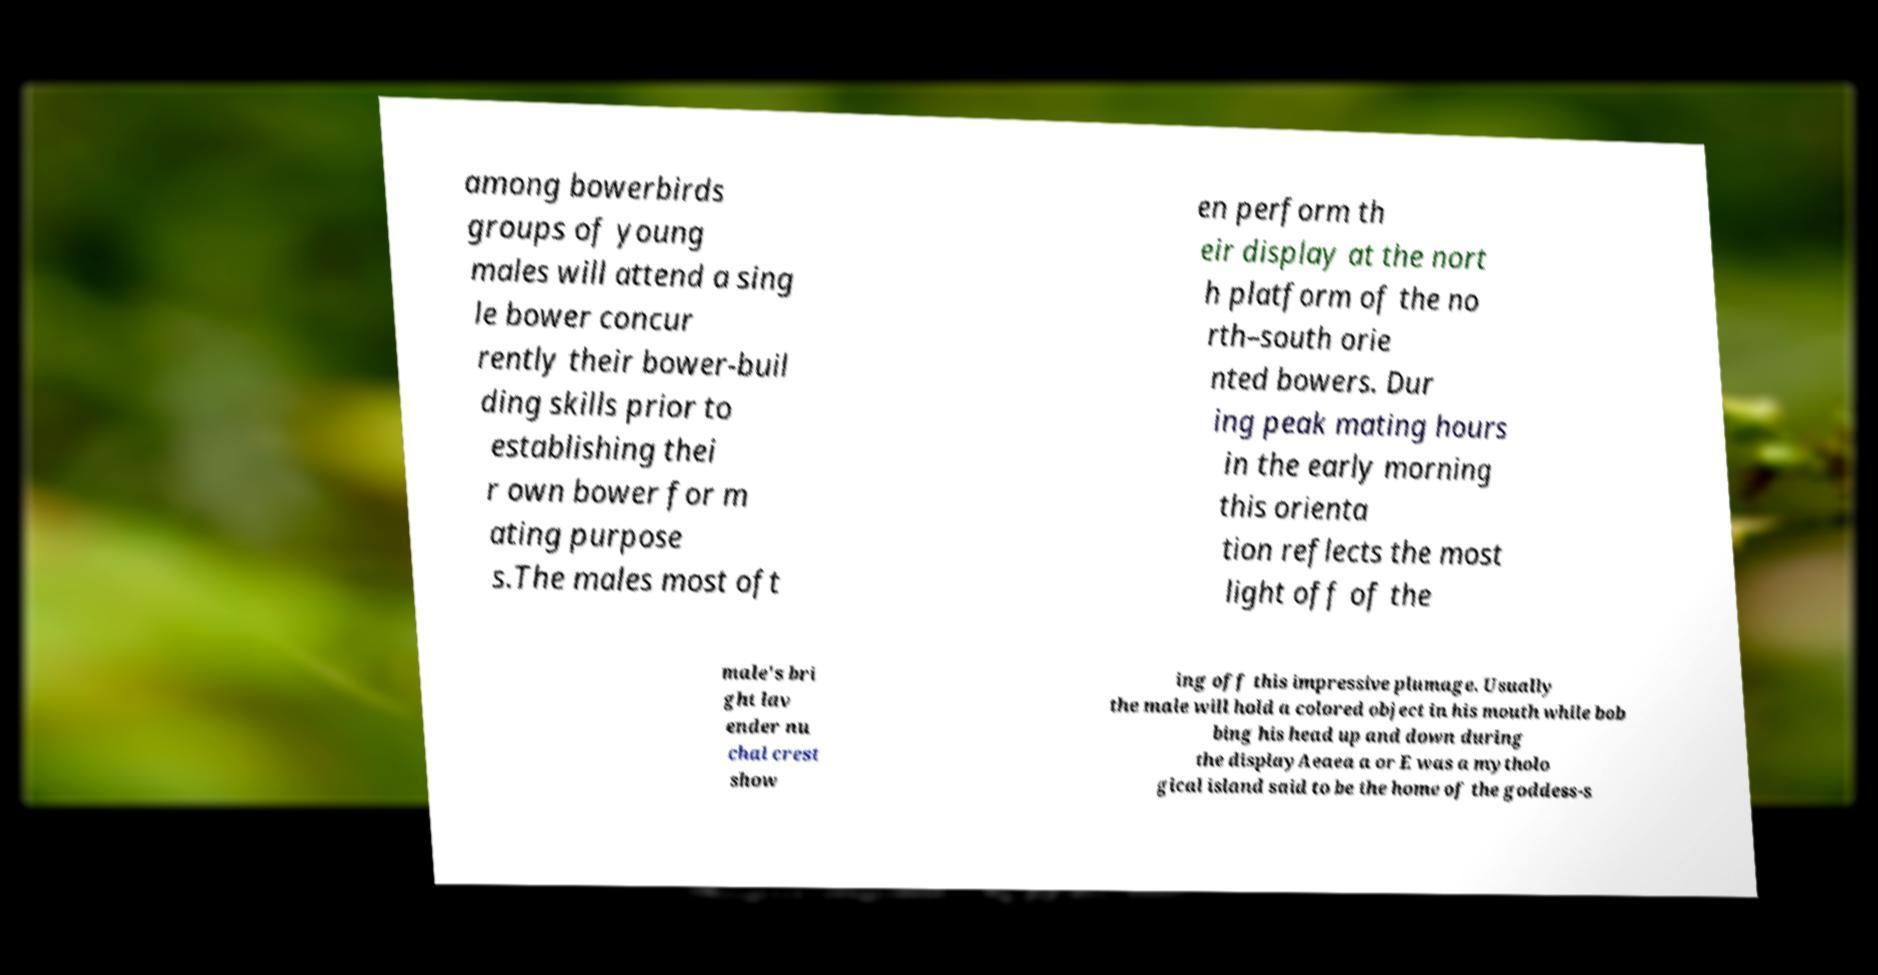Please read and relay the text visible in this image. What does it say? among bowerbirds groups of young males will attend a sing le bower concur rently their bower-buil ding skills prior to establishing thei r own bower for m ating purpose s.The males most oft en perform th eir display at the nort h platform of the no rth–south orie nted bowers. Dur ing peak mating hours in the early morning this orienta tion reflects the most light off of the male's bri ght lav ender nu chal crest show ing off this impressive plumage. Usually the male will hold a colored object in his mouth while bob bing his head up and down during the displayAeaea a or E was a mytholo gical island said to be the home of the goddess-s 